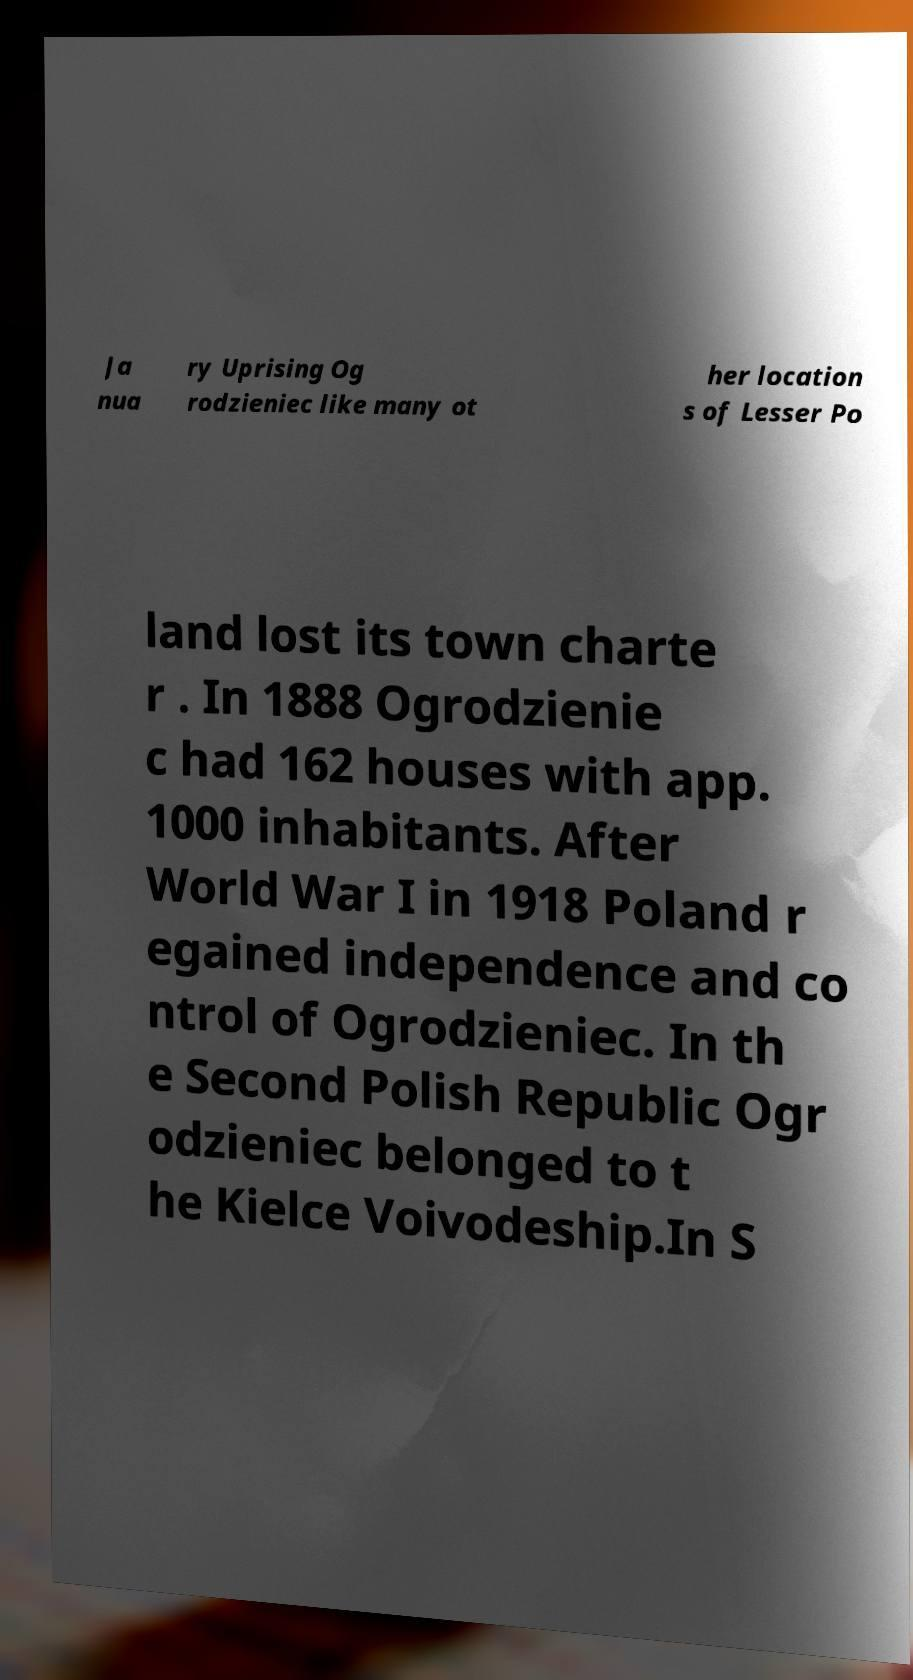For documentation purposes, I need the text within this image transcribed. Could you provide that? Ja nua ry Uprising Og rodzieniec like many ot her location s of Lesser Po land lost its town charte r . In 1888 Ogrodzienie c had 162 houses with app. 1000 inhabitants. After World War I in 1918 Poland r egained independence and co ntrol of Ogrodzieniec. In th e Second Polish Republic Ogr odzieniec belonged to t he Kielce Voivodeship.In S 